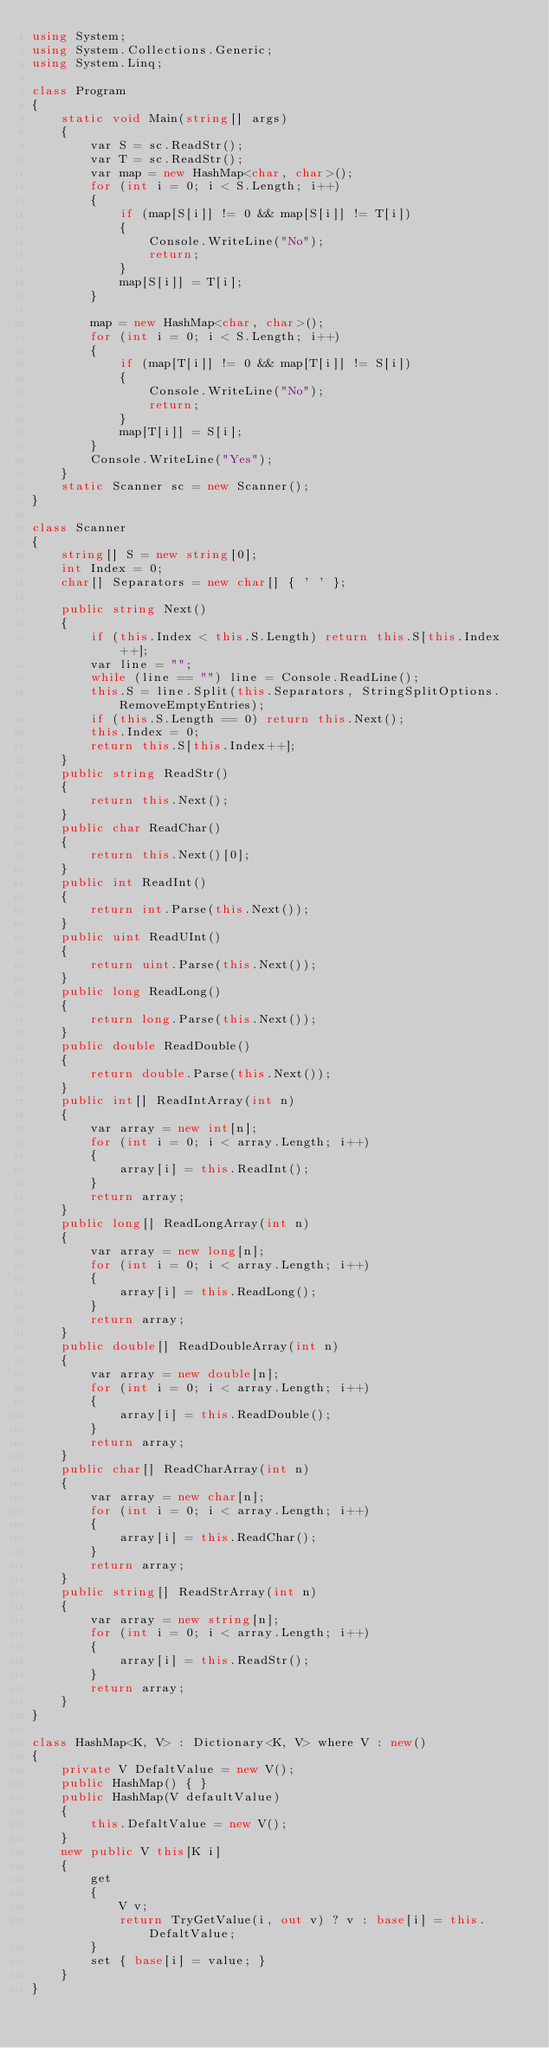<code> <loc_0><loc_0><loc_500><loc_500><_C#_>using System;
using System.Collections.Generic;
using System.Linq;

class Program
{
    static void Main(string[] args)
    {
        var S = sc.ReadStr();
        var T = sc.ReadStr();
        var map = new HashMap<char, char>();
        for (int i = 0; i < S.Length; i++)
        {
            if (map[S[i]] != 0 && map[S[i]] != T[i])
            {
                Console.WriteLine("No");
                return;
            }
            map[S[i]] = T[i];
        }

        map = new HashMap<char, char>();
        for (int i = 0; i < S.Length; i++)
        {
            if (map[T[i]] != 0 && map[T[i]] != S[i])
            {
                Console.WriteLine("No");
                return;
            }
            map[T[i]] = S[i];
        }
        Console.WriteLine("Yes");
    }
    static Scanner sc = new Scanner();
}

class Scanner
{
    string[] S = new string[0];
    int Index = 0;
    char[] Separators = new char[] { ' ' };

    public string Next()
    {
        if (this.Index < this.S.Length) return this.S[this.Index++];
        var line = "";
        while (line == "") line = Console.ReadLine();
        this.S = line.Split(this.Separators, StringSplitOptions.RemoveEmptyEntries);
        if (this.S.Length == 0) return this.Next();
        this.Index = 0;
        return this.S[this.Index++];
    }
    public string ReadStr()
    {
        return this.Next();
    }
    public char ReadChar()
    {
        return this.Next()[0];
    }
    public int ReadInt()
    {
        return int.Parse(this.Next());
    }
    public uint ReadUInt()
    {
        return uint.Parse(this.Next());
    }
    public long ReadLong()
    {
        return long.Parse(this.Next());
    }
    public double ReadDouble()
    {
        return double.Parse(this.Next());
    }
    public int[] ReadIntArray(int n)
    {
        var array = new int[n];
        for (int i = 0; i < array.Length; i++)
        {
            array[i] = this.ReadInt();
        }
        return array;
    }
    public long[] ReadLongArray(int n)
    {
        var array = new long[n];
        for (int i = 0; i < array.Length; i++)
        {
            array[i] = this.ReadLong();
        }
        return array;
    }
    public double[] ReadDoubleArray(int n)
    {
        var array = new double[n];
        for (int i = 0; i < array.Length; i++)
        {
            array[i] = this.ReadDouble();
        }
        return array;
    }
    public char[] ReadCharArray(int n)
    {
        var array = new char[n];
        for (int i = 0; i < array.Length; i++)
        {
            array[i] = this.ReadChar();
        }
        return array;
    }
    public string[] ReadStrArray(int n)
    {
        var array = new string[n];
        for (int i = 0; i < array.Length; i++)
        {
            array[i] = this.ReadStr();
        }
        return array;
    }
}

class HashMap<K, V> : Dictionary<K, V> where V : new()
{
    private V DefaltValue = new V();
    public HashMap() { }
    public HashMap(V defaultValue)
    {
        this.DefaltValue = new V();
    }
    new public V this[K i]
    {
        get
        {
            V v;
            return TryGetValue(i, out v) ? v : base[i] = this.DefaltValue;
        }
        set { base[i] = value; }
    }
}
</code> 